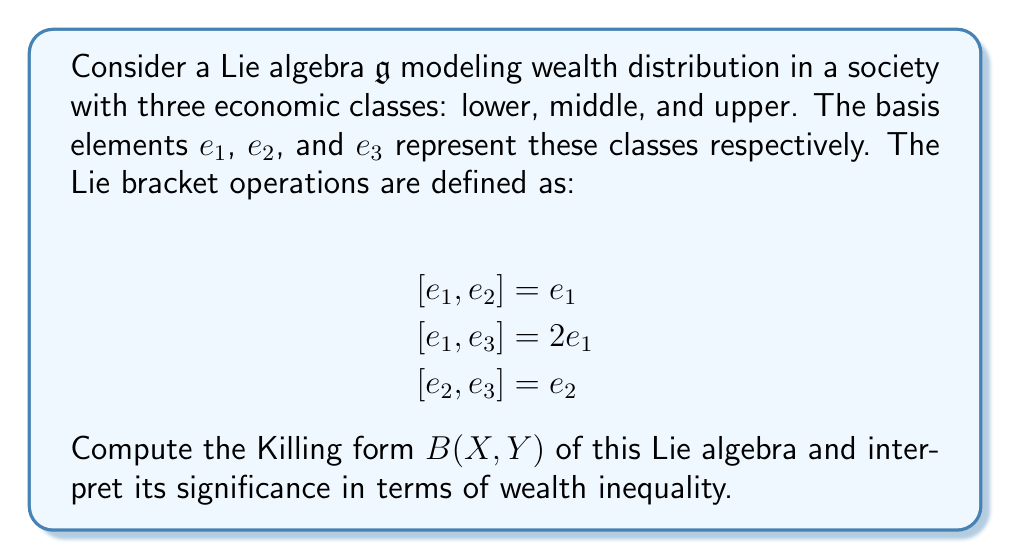Help me with this question. To compute the Killing form of this Lie algebra, we follow these steps:

1) The Killing form is defined as $B(X, Y) = \text{tr}(\text{ad}_X \circ \text{ad}_Y)$, where $\text{ad}_X(Z) = [X, Z]$ and $\text{tr}$ denotes the trace.

2) First, we need to find the matrix representations of $\text{ad}_{e_1}$, $\text{ad}_{e_2}$, and $\text{ad}_{e_3}$:

   $\text{ad}_{e_1} = \begin{pmatrix} 0 & 0 & 0 \\ 0 & 0 & 0 \\ 0 & 0 & 0 \end{pmatrix}$

   $\text{ad}_{e_2} = \begin{pmatrix} -1 & 0 & 0 \\ 0 & 0 & 0 \\ 0 & 0 & 0 \end{pmatrix}$

   $\text{ad}_{e_3} = \begin{pmatrix} -2 & 0 & 0 \\ 0 & -1 & 0 \\ 0 & 0 & 0 \end{pmatrix}$

3) Now we can compute $B(e_i, e_j)$ for all pairs $i, j \in \{1, 2, 3\}$:

   $B(e_1, e_1) = \text{tr}(\text{ad}_{e_1} \circ \text{ad}_{e_1}) = 0$
   $B(e_1, e_2) = B(e_2, e_1) = \text{tr}(\text{ad}_{e_1} \circ \text{ad}_{e_2}) = 0$
   $B(e_1, e_3) = B(e_3, e_1) = \text{tr}(\text{ad}_{e_1} \circ \text{ad}_{e_3}) = 0$
   $B(e_2, e_2) = \text{tr}(\text{ad}_{e_2} \circ \text{ad}_{e_2}) = 1$
   $B(e_2, e_3) = B(e_3, e_2) = \text{tr}(\text{ad}_{e_2} \circ \text{ad}_{e_3}) = 2$
   $B(e_3, e_3) = \text{tr}(\text{ad}_{e_3} \circ \text{ad}_{e_3}) = 5$

4) The Killing form can be represented as a matrix:

   $B = \begin{pmatrix} 0 & 0 & 0 \\ 0 & 1 & 2 \\ 0 & 2 & 5 \end{pmatrix}$

Interpretation: The Killing form reveals the structural inequalities in this economic model. The lower class ($e_1$) has no impact on the overall structure (all zeros in the first row and column), indicating a lack of economic power. The upper class ($e_3$) has the largest self-interaction term (5), suggesting concentrated wealth and influence. The middle class ($e_2$) shows some interaction with both itself and the upper class, but not with the lower class, potentially indicating a widening gap between lower and middle classes.
Answer: The Killing form of the given Lie algebra is:

$$B = \begin{pmatrix} 0 & 0 & 0 \\ 0 & 1 & 2 \\ 0 & 2 & 5 \end{pmatrix}$$

This form reveals significant wealth inequality, with the lower class having no impact, the upper class having the most influence, and the middle class showing limited interaction. 